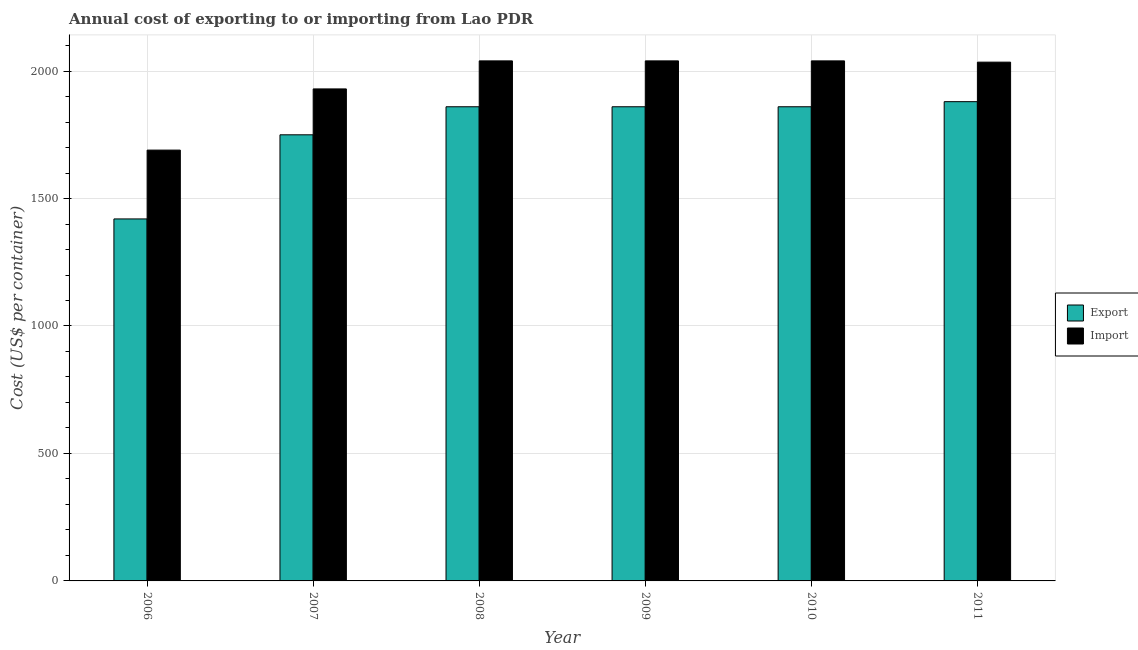How many different coloured bars are there?
Your answer should be very brief. 2. How many bars are there on the 4th tick from the right?
Your answer should be very brief. 2. What is the label of the 5th group of bars from the left?
Make the answer very short. 2010. What is the import cost in 2007?
Give a very brief answer. 1930. Across all years, what is the maximum import cost?
Your answer should be very brief. 2040. Across all years, what is the minimum import cost?
Offer a very short reply. 1690. In which year was the export cost maximum?
Offer a very short reply. 2011. In which year was the export cost minimum?
Make the answer very short. 2006. What is the total import cost in the graph?
Offer a terse response. 1.18e+04. What is the difference between the export cost in 2007 and that in 2008?
Provide a short and direct response. -110. What is the difference between the import cost in 2008 and the export cost in 2007?
Offer a very short reply. 110. What is the average import cost per year?
Your answer should be compact. 1962.5. In how many years, is the export cost greater than 700 US$?
Keep it short and to the point. 6. What is the ratio of the export cost in 2007 to that in 2011?
Provide a short and direct response. 0.93. Is the export cost in 2007 less than that in 2009?
Give a very brief answer. Yes. Is the difference between the import cost in 2006 and 2009 greater than the difference between the export cost in 2006 and 2009?
Make the answer very short. No. What is the difference between the highest and the lowest export cost?
Your response must be concise. 460. What does the 2nd bar from the left in 2010 represents?
Ensure brevity in your answer.  Import. What does the 1st bar from the right in 2007 represents?
Ensure brevity in your answer.  Import. How many years are there in the graph?
Give a very brief answer. 6. Are the values on the major ticks of Y-axis written in scientific E-notation?
Give a very brief answer. No. Does the graph contain any zero values?
Offer a terse response. No. Does the graph contain grids?
Provide a short and direct response. Yes. How many legend labels are there?
Give a very brief answer. 2. What is the title of the graph?
Your answer should be very brief. Annual cost of exporting to or importing from Lao PDR. Does "Forest" appear as one of the legend labels in the graph?
Your answer should be compact. No. What is the label or title of the Y-axis?
Keep it short and to the point. Cost (US$ per container). What is the Cost (US$ per container) in Export in 2006?
Your answer should be very brief. 1420. What is the Cost (US$ per container) of Import in 2006?
Your answer should be very brief. 1690. What is the Cost (US$ per container) in Export in 2007?
Your answer should be very brief. 1750. What is the Cost (US$ per container) in Import in 2007?
Your answer should be compact. 1930. What is the Cost (US$ per container) in Export in 2008?
Your answer should be compact. 1860. What is the Cost (US$ per container) of Import in 2008?
Offer a very short reply. 2040. What is the Cost (US$ per container) of Export in 2009?
Provide a succinct answer. 1860. What is the Cost (US$ per container) of Import in 2009?
Offer a very short reply. 2040. What is the Cost (US$ per container) in Export in 2010?
Offer a terse response. 1860. What is the Cost (US$ per container) in Import in 2010?
Offer a terse response. 2040. What is the Cost (US$ per container) in Export in 2011?
Keep it short and to the point. 1880. What is the Cost (US$ per container) in Import in 2011?
Your response must be concise. 2035. Across all years, what is the maximum Cost (US$ per container) in Export?
Provide a succinct answer. 1880. Across all years, what is the maximum Cost (US$ per container) of Import?
Provide a short and direct response. 2040. Across all years, what is the minimum Cost (US$ per container) of Export?
Provide a succinct answer. 1420. Across all years, what is the minimum Cost (US$ per container) of Import?
Offer a very short reply. 1690. What is the total Cost (US$ per container) of Export in the graph?
Ensure brevity in your answer.  1.06e+04. What is the total Cost (US$ per container) in Import in the graph?
Provide a short and direct response. 1.18e+04. What is the difference between the Cost (US$ per container) of Export in 2006 and that in 2007?
Your answer should be very brief. -330. What is the difference between the Cost (US$ per container) in Import in 2006 and that in 2007?
Your answer should be very brief. -240. What is the difference between the Cost (US$ per container) of Export in 2006 and that in 2008?
Make the answer very short. -440. What is the difference between the Cost (US$ per container) of Import in 2006 and that in 2008?
Make the answer very short. -350. What is the difference between the Cost (US$ per container) of Export in 2006 and that in 2009?
Offer a very short reply. -440. What is the difference between the Cost (US$ per container) in Import in 2006 and that in 2009?
Your answer should be very brief. -350. What is the difference between the Cost (US$ per container) in Export in 2006 and that in 2010?
Provide a succinct answer. -440. What is the difference between the Cost (US$ per container) in Import in 2006 and that in 2010?
Give a very brief answer. -350. What is the difference between the Cost (US$ per container) of Export in 2006 and that in 2011?
Provide a succinct answer. -460. What is the difference between the Cost (US$ per container) in Import in 2006 and that in 2011?
Give a very brief answer. -345. What is the difference between the Cost (US$ per container) in Export in 2007 and that in 2008?
Offer a terse response. -110. What is the difference between the Cost (US$ per container) in Import in 2007 and that in 2008?
Give a very brief answer. -110. What is the difference between the Cost (US$ per container) of Export in 2007 and that in 2009?
Your response must be concise. -110. What is the difference between the Cost (US$ per container) of Import in 2007 and that in 2009?
Your answer should be compact. -110. What is the difference between the Cost (US$ per container) in Export in 2007 and that in 2010?
Make the answer very short. -110. What is the difference between the Cost (US$ per container) in Import in 2007 and that in 2010?
Make the answer very short. -110. What is the difference between the Cost (US$ per container) of Export in 2007 and that in 2011?
Give a very brief answer. -130. What is the difference between the Cost (US$ per container) of Import in 2007 and that in 2011?
Offer a very short reply. -105. What is the difference between the Cost (US$ per container) in Export in 2008 and that in 2009?
Provide a short and direct response. 0. What is the difference between the Cost (US$ per container) of Export in 2008 and that in 2010?
Provide a short and direct response. 0. What is the difference between the Cost (US$ per container) of Export in 2008 and that in 2011?
Provide a succinct answer. -20. What is the difference between the Cost (US$ per container) of Export in 2009 and that in 2010?
Provide a succinct answer. 0. What is the difference between the Cost (US$ per container) of Import in 2009 and that in 2010?
Provide a short and direct response. 0. What is the difference between the Cost (US$ per container) of Export in 2009 and that in 2011?
Give a very brief answer. -20. What is the difference between the Cost (US$ per container) in Export in 2010 and that in 2011?
Offer a very short reply. -20. What is the difference between the Cost (US$ per container) of Export in 2006 and the Cost (US$ per container) of Import in 2007?
Keep it short and to the point. -510. What is the difference between the Cost (US$ per container) of Export in 2006 and the Cost (US$ per container) of Import in 2008?
Ensure brevity in your answer.  -620. What is the difference between the Cost (US$ per container) in Export in 2006 and the Cost (US$ per container) in Import in 2009?
Your answer should be very brief. -620. What is the difference between the Cost (US$ per container) in Export in 2006 and the Cost (US$ per container) in Import in 2010?
Ensure brevity in your answer.  -620. What is the difference between the Cost (US$ per container) in Export in 2006 and the Cost (US$ per container) in Import in 2011?
Offer a very short reply. -615. What is the difference between the Cost (US$ per container) in Export in 2007 and the Cost (US$ per container) in Import in 2008?
Offer a very short reply. -290. What is the difference between the Cost (US$ per container) in Export in 2007 and the Cost (US$ per container) in Import in 2009?
Make the answer very short. -290. What is the difference between the Cost (US$ per container) of Export in 2007 and the Cost (US$ per container) of Import in 2010?
Offer a very short reply. -290. What is the difference between the Cost (US$ per container) in Export in 2007 and the Cost (US$ per container) in Import in 2011?
Your response must be concise. -285. What is the difference between the Cost (US$ per container) of Export in 2008 and the Cost (US$ per container) of Import in 2009?
Keep it short and to the point. -180. What is the difference between the Cost (US$ per container) in Export in 2008 and the Cost (US$ per container) in Import in 2010?
Your answer should be compact. -180. What is the difference between the Cost (US$ per container) of Export in 2008 and the Cost (US$ per container) of Import in 2011?
Give a very brief answer. -175. What is the difference between the Cost (US$ per container) in Export in 2009 and the Cost (US$ per container) in Import in 2010?
Ensure brevity in your answer.  -180. What is the difference between the Cost (US$ per container) of Export in 2009 and the Cost (US$ per container) of Import in 2011?
Provide a short and direct response. -175. What is the difference between the Cost (US$ per container) of Export in 2010 and the Cost (US$ per container) of Import in 2011?
Offer a terse response. -175. What is the average Cost (US$ per container) in Export per year?
Your answer should be very brief. 1771.67. What is the average Cost (US$ per container) in Import per year?
Your answer should be compact. 1962.5. In the year 2006, what is the difference between the Cost (US$ per container) of Export and Cost (US$ per container) of Import?
Keep it short and to the point. -270. In the year 2007, what is the difference between the Cost (US$ per container) of Export and Cost (US$ per container) of Import?
Keep it short and to the point. -180. In the year 2008, what is the difference between the Cost (US$ per container) in Export and Cost (US$ per container) in Import?
Give a very brief answer. -180. In the year 2009, what is the difference between the Cost (US$ per container) of Export and Cost (US$ per container) of Import?
Ensure brevity in your answer.  -180. In the year 2010, what is the difference between the Cost (US$ per container) of Export and Cost (US$ per container) of Import?
Ensure brevity in your answer.  -180. In the year 2011, what is the difference between the Cost (US$ per container) in Export and Cost (US$ per container) in Import?
Give a very brief answer. -155. What is the ratio of the Cost (US$ per container) in Export in 2006 to that in 2007?
Your answer should be compact. 0.81. What is the ratio of the Cost (US$ per container) of Import in 2006 to that in 2007?
Your answer should be compact. 0.88. What is the ratio of the Cost (US$ per container) of Export in 2006 to that in 2008?
Ensure brevity in your answer.  0.76. What is the ratio of the Cost (US$ per container) in Import in 2006 to that in 2008?
Your response must be concise. 0.83. What is the ratio of the Cost (US$ per container) of Export in 2006 to that in 2009?
Provide a succinct answer. 0.76. What is the ratio of the Cost (US$ per container) in Import in 2006 to that in 2009?
Offer a terse response. 0.83. What is the ratio of the Cost (US$ per container) in Export in 2006 to that in 2010?
Your response must be concise. 0.76. What is the ratio of the Cost (US$ per container) of Import in 2006 to that in 2010?
Provide a short and direct response. 0.83. What is the ratio of the Cost (US$ per container) in Export in 2006 to that in 2011?
Give a very brief answer. 0.76. What is the ratio of the Cost (US$ per container) in Import in 2006 to that in 2011?
Your answer should be compact. 0.83. What is the ratio of the Cost (US$ per container) of Export in 2007 to that in 2008?
Provide a succinct answer. 0.94. What is the ratio of the Cost (US$ per container) of Import in 2007 to that in 2008?
Your response must be concise. 0.95. What is the ratio of the Cost (US$ per container) in Export in 2007 to that in 2009?
Keep it short and to the point. 0.94. What is the ratio of the Cost (US$ per container) of Import in 2007 to that in 2009?
Offer a very short reply. 0.95. What is the ratio of the Cost (US$ per container) of Export in 2007 to that in 2010?
Ensure brevity in your answer.  0.94. What is the ratio of the Cost (US$ per container) in Import in 2007 to that in 2010?
Your answer should be very brief. 0.95. What is the ratio of the Cost (US$ per container) in Export in 2007 to that in 2011?
Keep it short and to the point. 0.93. What is the ratio of the Cost (US$ per container) of Import in 2007 to that in 2011?
Offer a terse response. 0.95. What is the ratio of the Cost (US$ per container) of Export in 2008 to that in 2009?
Provide a short and direct response. 1. What is the ratio of the Cost (US$ per container) of Import in 2008 to that in 2009?
Provide a succinct answer. 1. What is the ratio of the Cost (US$ per container) in Export in 2008 to that in 2011?
Keep it short and to the point. 0.99. What is the ratio of the Cost (US$ per container) of Import in 2008 to that in 2011?
Your answer should be compact. 1. What is the ratio of the Cost (US$ per container) in Import in 2009 to that in 2010?
Give a very brief answer. 1. What is the ratio of the Cost (US$ per container) of Export in 2009 to that in 2011?
Offer a terse response. 0.99. What is the ratio of the Cost (US$ per container) of Import in 2009 to that in 2011?
Your response must be concise. 1. What is the ratio of the Cost (US$ per container) of Export in 2010 to that in 2011?
Provide a succinct answer. 0.99. What is the ratio of the Cost (US$ per container) of Import in 2010 to that in 2011?
Make the answer very short. 1. What is the difference between the highest and the second highest Cost (US$ per container) in Import?
Provide a short and direct response. 0. What is the difference between the highest and the lowest Cost (US$ per container) of Export?
Ensure brevity in your answer.  460. What is the difference between the highest and the lowest Cost (US$ per container) in Import?
Your response must be concise. 350. 